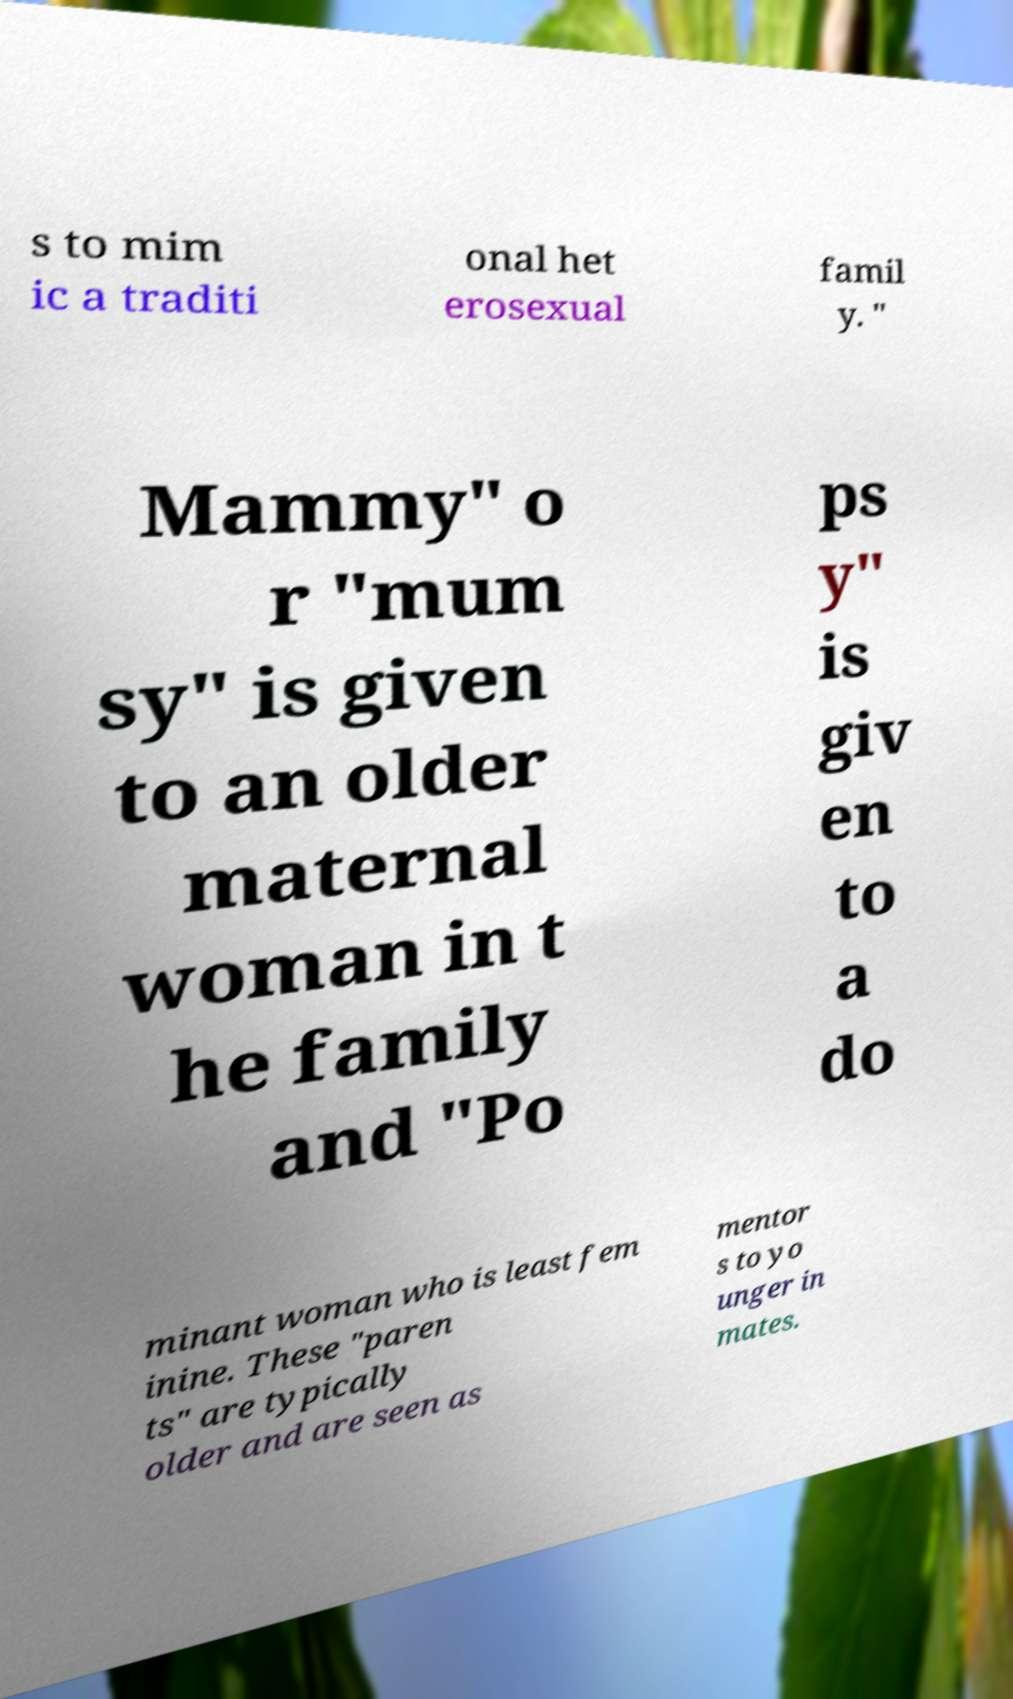There's text embedded in this image that I need extracted. Can you transcribe it verbatim? s to mim ic a traditi onal het erosexual famil y. " Mammy" o r "mum sy" is given to an older maternal woman in t he family and "Po ps y" is giv en to a do minant woman who is least fem inine. These "paren ts" are typically older and are seen as mentor s to yo unger in mates. 